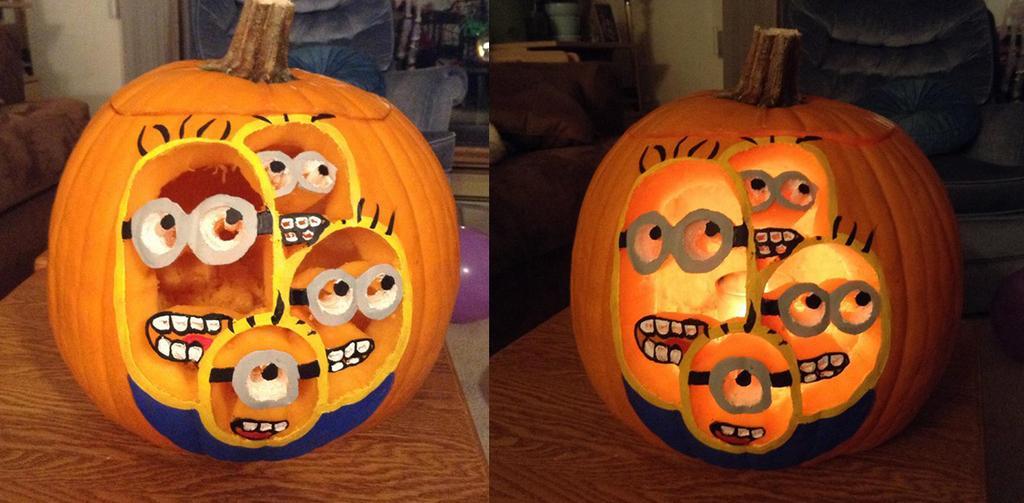Can you describe this image briefly? Here we can see collage of two images in this we can find pumpkins, balloon, sofa chairs and blurry background. 